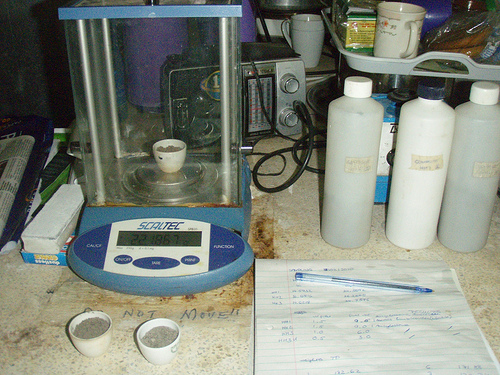<image>
Can you confirm if the bottle is behind the pencil? Yes. From this viewpoint, the bottle is positioned behind the pencil, with the pencil partially or fully occluding the bottle. 